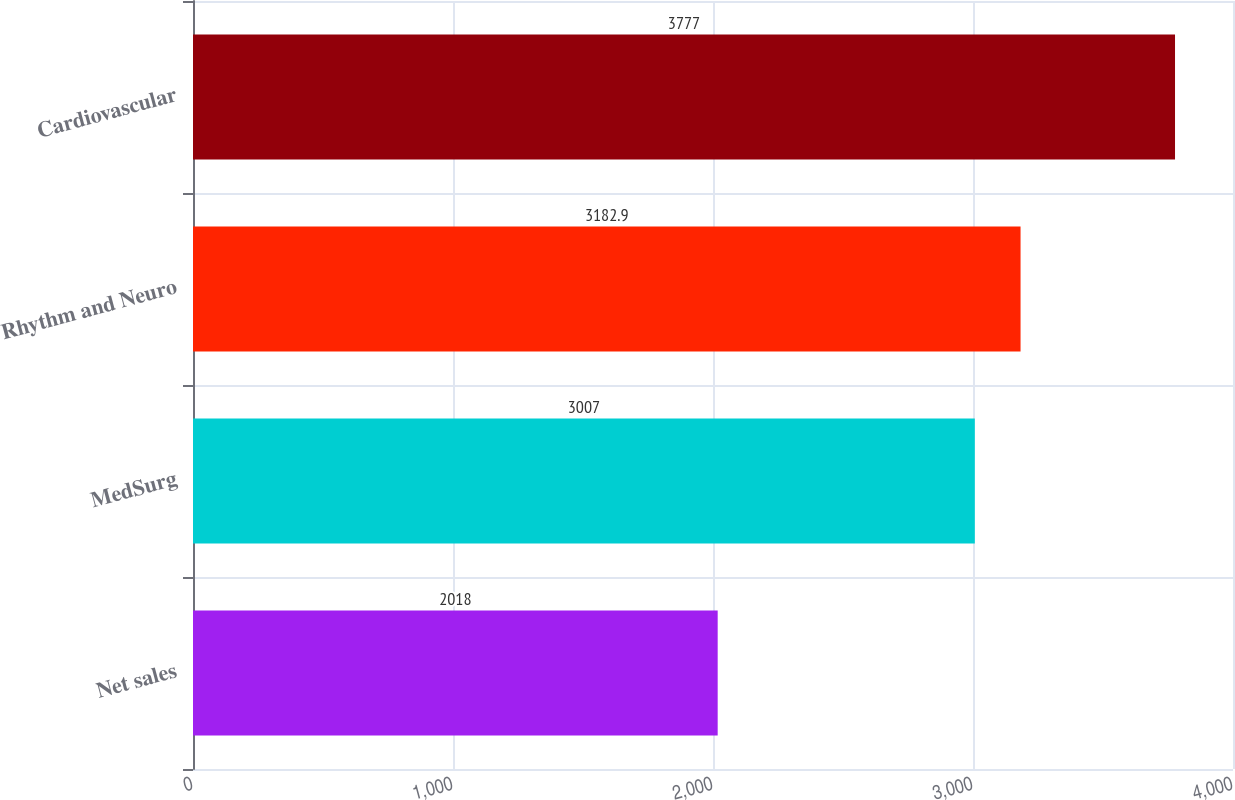Convert chart to OTSL. <chart><loc_0><loc_0><loc_500><loc_500><bar_chart><fcel>Net sales<fcel>MedSurg<fcel>Rhythm and Neuro<fcel>Cardiovascular<nl><fcel>2018<fcel>3007<fcel>3182.9<fcel>3777<nl></chart> 